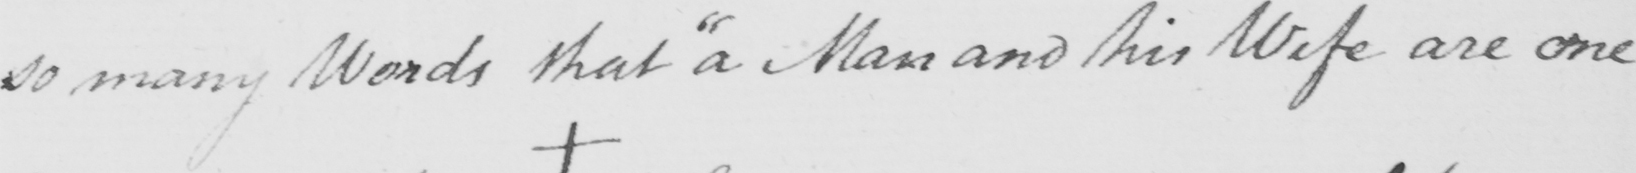What text is written in this handwritten line? so many Words that  " a Man and his Wife are one 